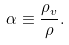<formula> <loc_0><loc_0><loc_500><loc_500>\alpha \equiv \frac { \rho _ { v } } \rho .</formula> 